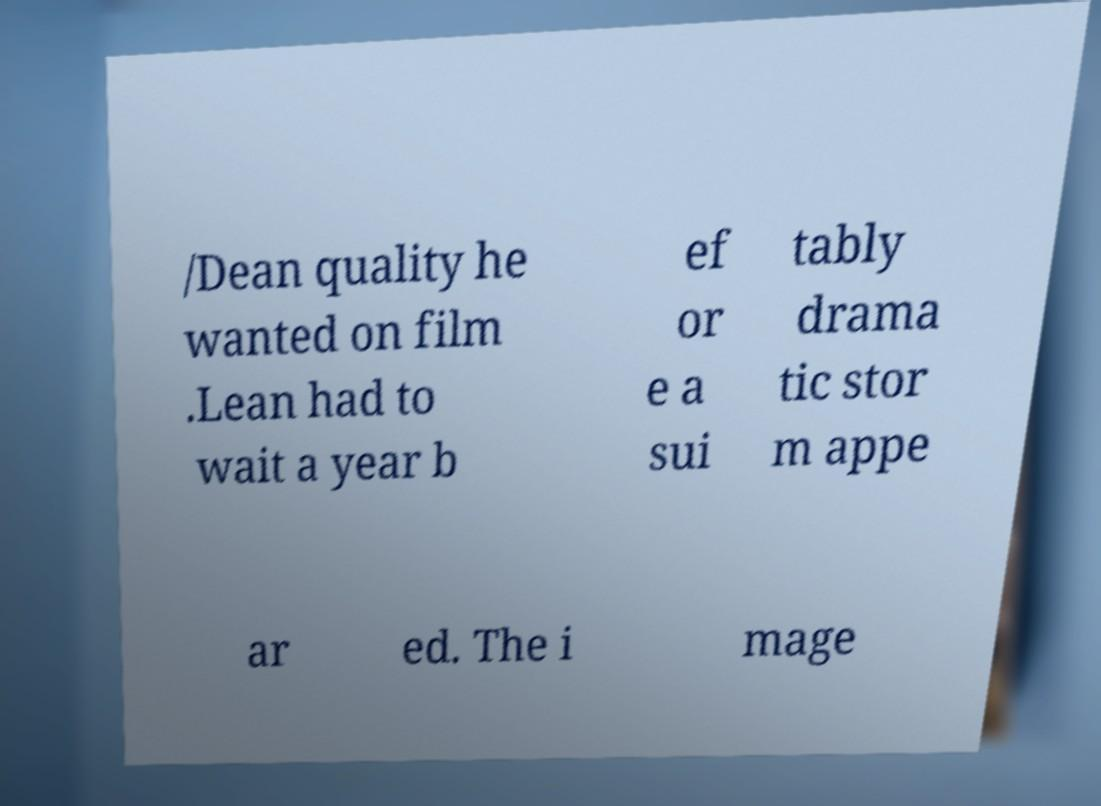What messages or text are displayed in this image? I need them in a readable, typed format. /Dean quality he wanted on film .Lean had to wait a year b ef or e a sui tably drama tic stor m appe ar ed. The i mage 